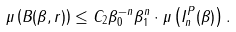Convert formula to latex. <formula><loc_0><loc_0><loc_500><loc_500>\mu \left ( B ( \beta , r ) \right ) \leq C _ { 2 } \beta _ { 0 } ^ { - n } \beta _ { 1 } ^ { n } \cdot \mu \left ( I _ { n } ^ { P } ( \beta ) \right ) .</formula> 